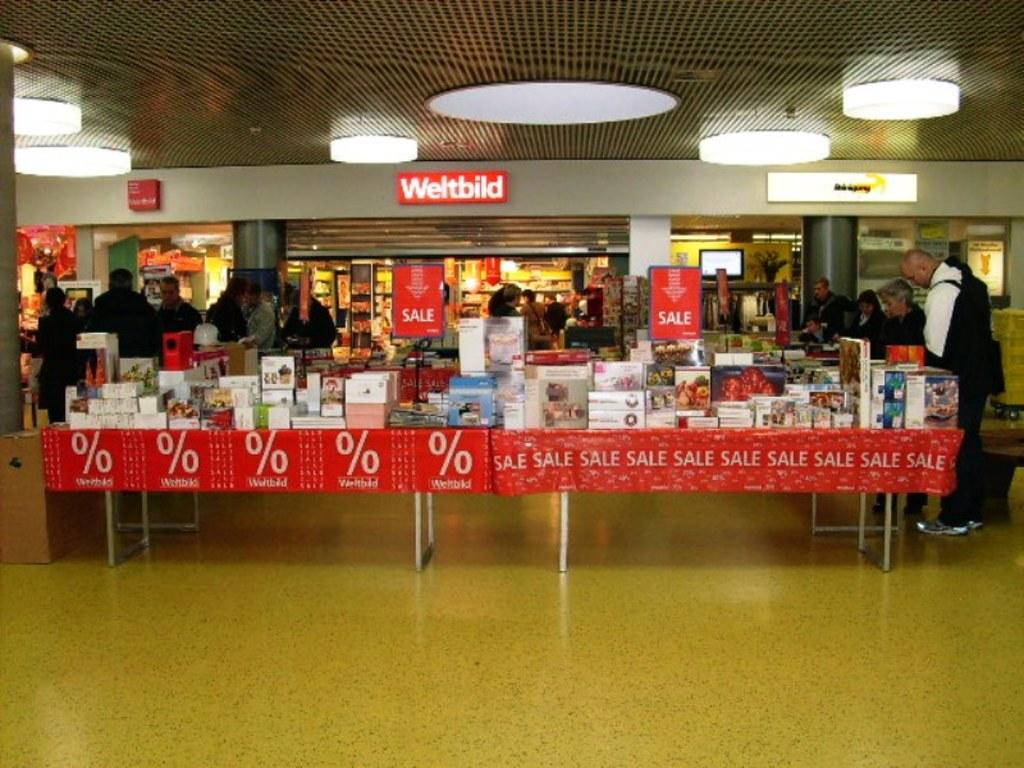<image>
Create a compact narrative representing the image presented. A Weltbild store in a mall area advertising a % sale 